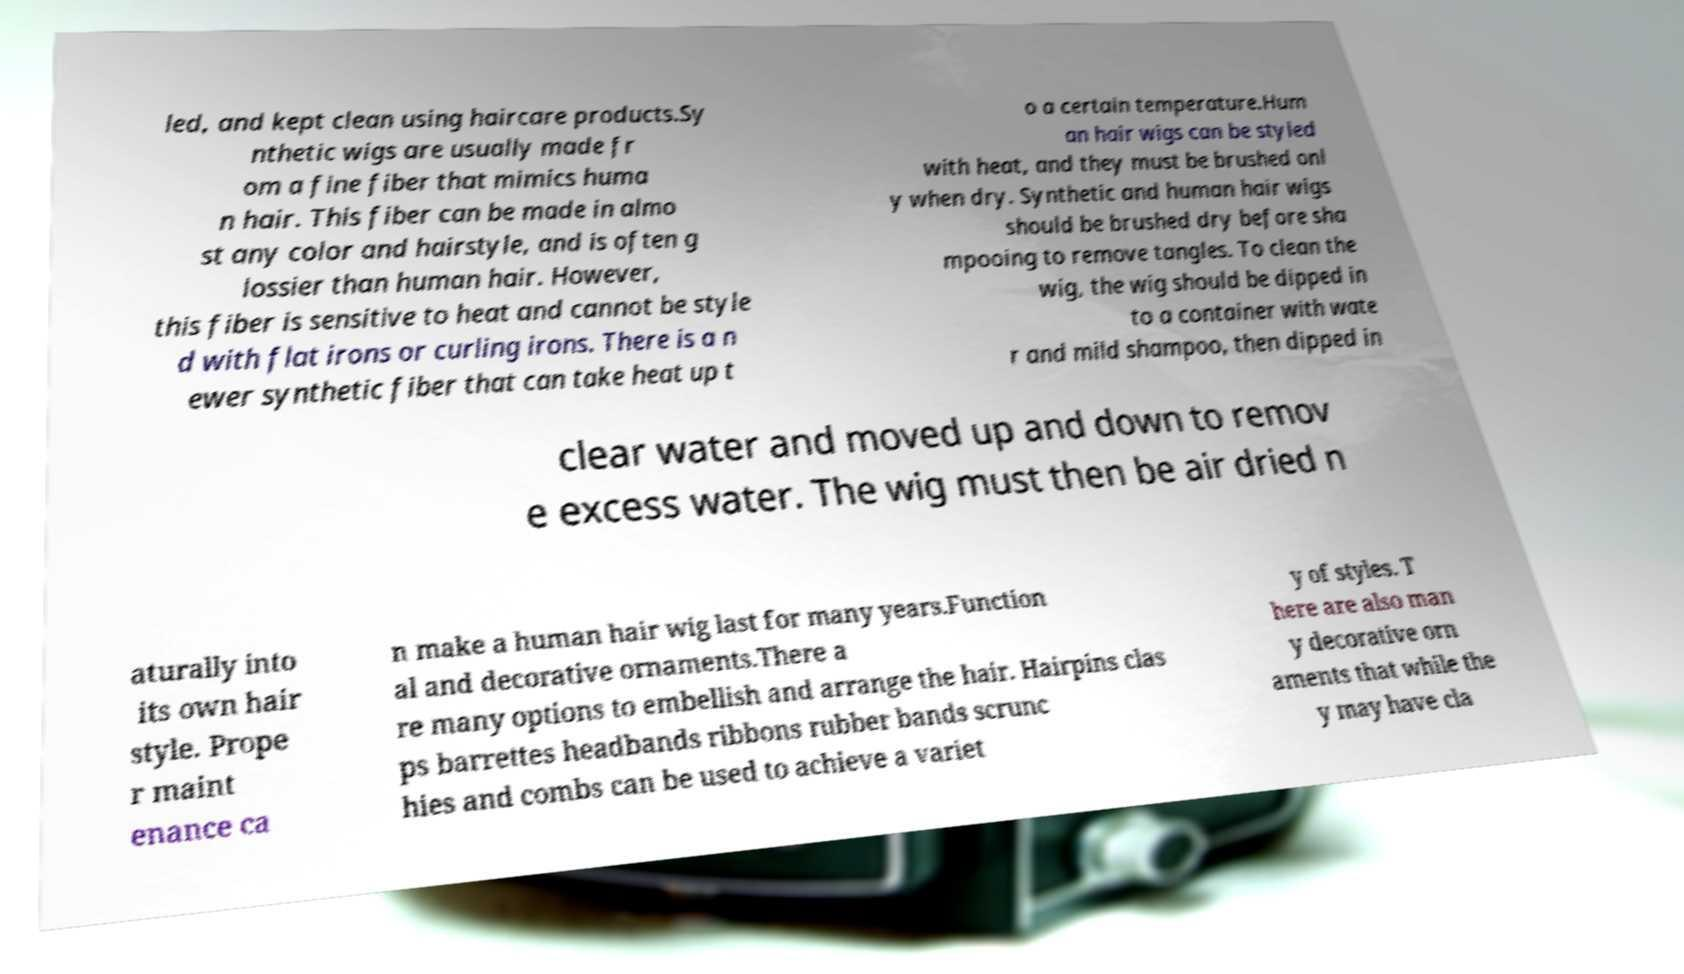Can you read and provide the text displayed in the image?This photo seems to have some interesting text. Can you extract and type it out for me? led, and kept clean using haircare products.Sy nthetic wigs are usually made fr om a fine fiber that mimics huma n hair. This fiber can be made in almo st any color and hairstyle, and is often g lossier than human hair. However, this fiber is sensitive to heat and cannot be style d with flat irons or curling irons. There is a n ewer synthetic fiber that can take heat up t o a certain temperature.Hum an hair wigs can be styled with heat, and they must be brushed onl y when dry. Synthetic and human hair wigs should be brushed dry before sha mpooing to remove tangles. To clean the wig, the wig should be dipped in to a container with wate r and mild shampoo, then dipped in clear water and moved up and down to remov e excess water. The wig must then be air dried n aturally into its own hair style. Prope r maint enance ca n make a human hair wig last for many years.Function al and decorative ornaments.There a re many options to embellish and arrange the hair. Hairpins clas ps barrettes headbands ribbons rubber bands scrunc hies and combs can be used to achieve a variet y of styles. T here are also man y decorative orn aments that while the y may have cla 